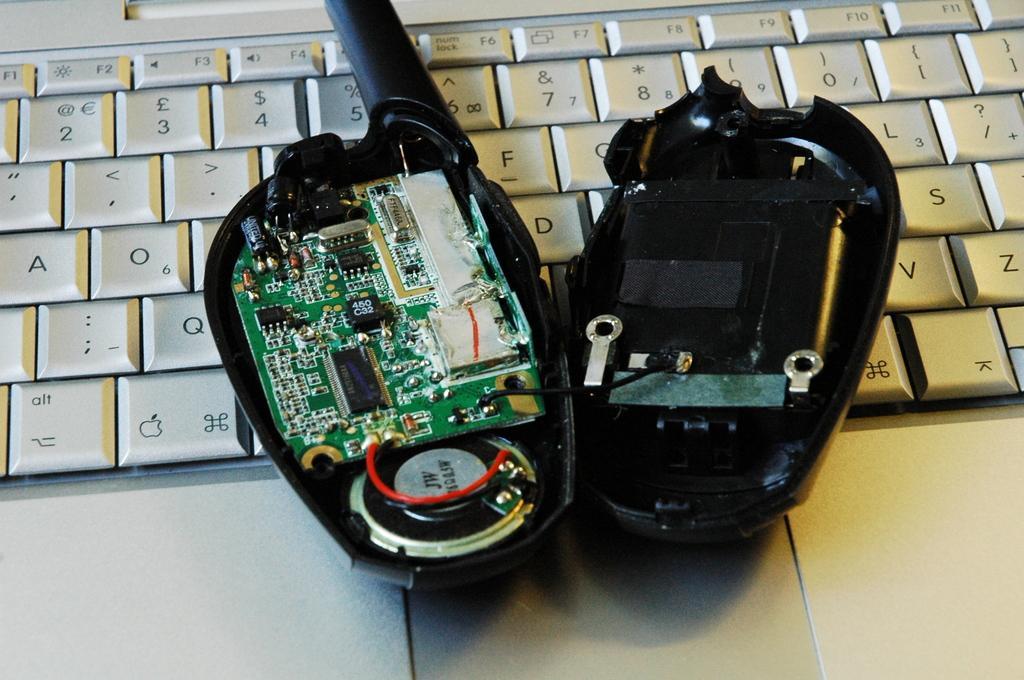Can you describe this image briefly? In the image there is a opened walkie talkie on a laptop. 